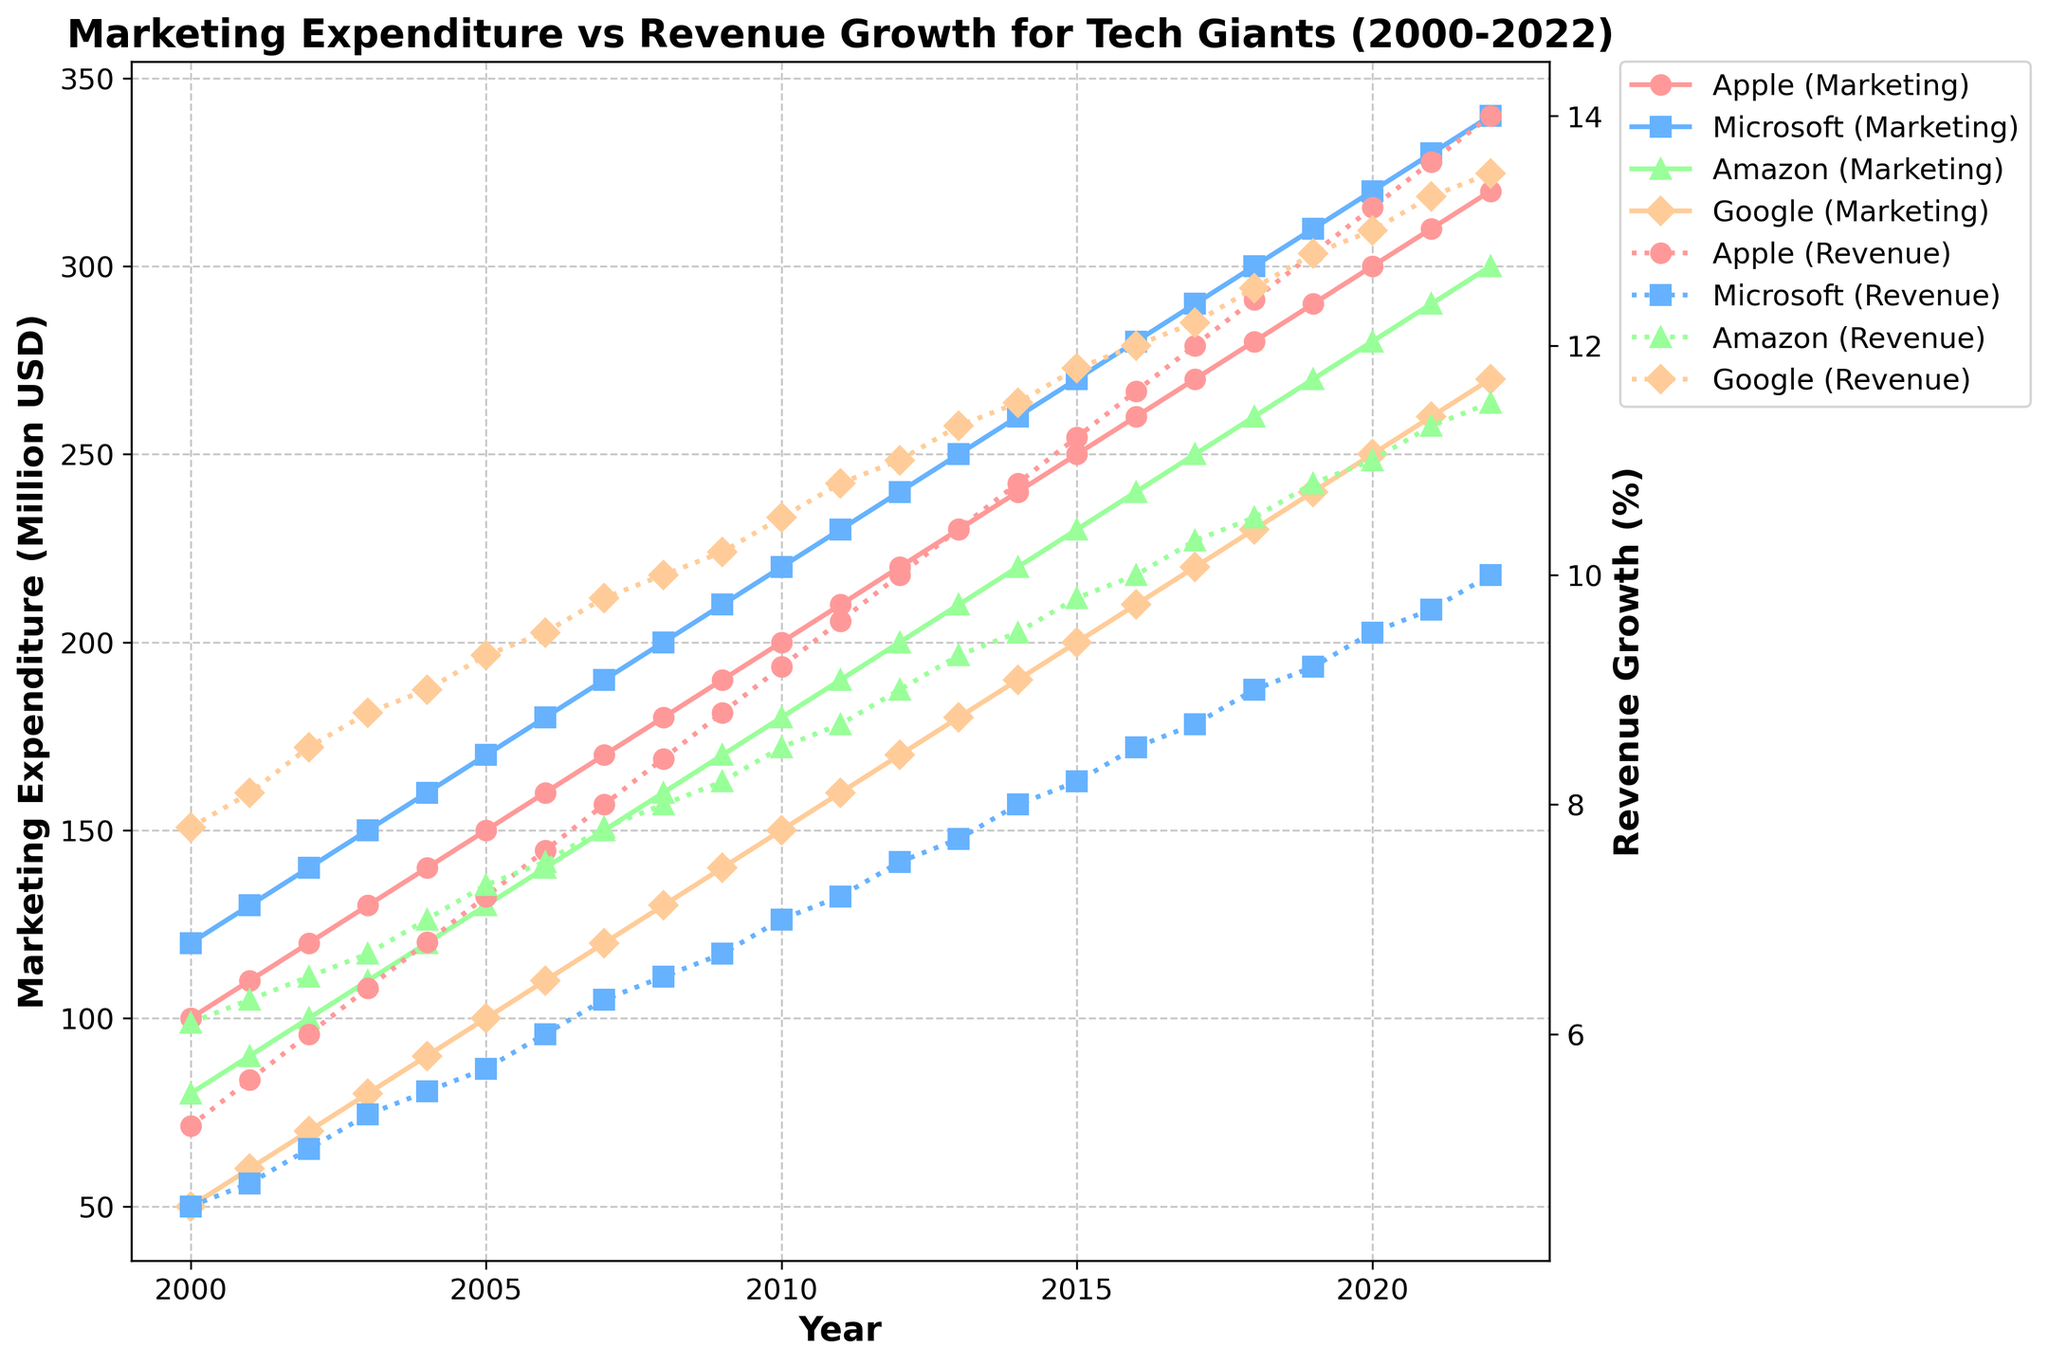What is the general trend of Apple’s marketing expenditure from 2000 to 2022? Looking at the plot, Apple’s marketing expenditure shows a consistent upward trend from 2000 to 2022, continually increasing year over year.
Answer: Increasing Which company had the highest marketing expenditure in 2022? By referring to the lines on the left y-axis for the year 2022, it is clear that Microsoft had the highest marketing expenditure in 2022.
Answer: Microsoft How does the revenue growth of Google compare to Amazon in 2018? To compare the revenue growth, look at the lines denoting revenue growth on the right y-axis for the year 2018. Google's line is higher than Amazon’s, indicating higher revenue growth.
Answer: Google had higher revenue growth Between which years did Apple see the highest increase in revenue growth? Observing the revenue growth line for Apple on the right y-axis, the steepest increase appears between 2019 and 2020.
Answer: 2019 to 2020 What is the difference in marketing expenditure between Apple and Amazon in 2010? For 2010, find the marketing expenditure values and compute the difference: Apple (200 million USD) minus Amazon (180 million USD) equals 20 million USD.
Answer: 20 million USD What is the overall relationship between marketing expenditure and revenue growth for Google? By examining Google’s lines, both marketing expenditure and revenue growth show a positive correlation over the years as both metrics increase consistently.
Answer: Positive correlation Which company had the lowest revenue growth in 2005, and what was the value? Check the revenue growth line for each company in 2005; Microsoft has the lowest value, which is 5.7%.
Answer: Microsoft, 5.7% How did Amazon's marketing expenditure change from 2002 to 2003? Locate the marketing expenditure values for Amazon in 2002 and 2003 and find the difference: 110 million USD in 2003 minus 100 million USD in 2002 equals an increase of 10 million USD.
Answer: Increased by 10 million USD During which period did Microsoft have a relatively flat trend in revenue growth? Observing Microsoft’s revenue growth line, there is a relatively flat trend from 2006 to 2009 where the growth rate changes only slightly each year.
Answer: 2006 to 2009 Which company had the most significant growth in marketing expenditure from 2000 to 2022? By comparing the marketing expenditure increase for all companies from 2000 to 2022, Microsoft had the most significant growth, as the difference is from 120 million to 340 million USD.
Answer: Microsoft 